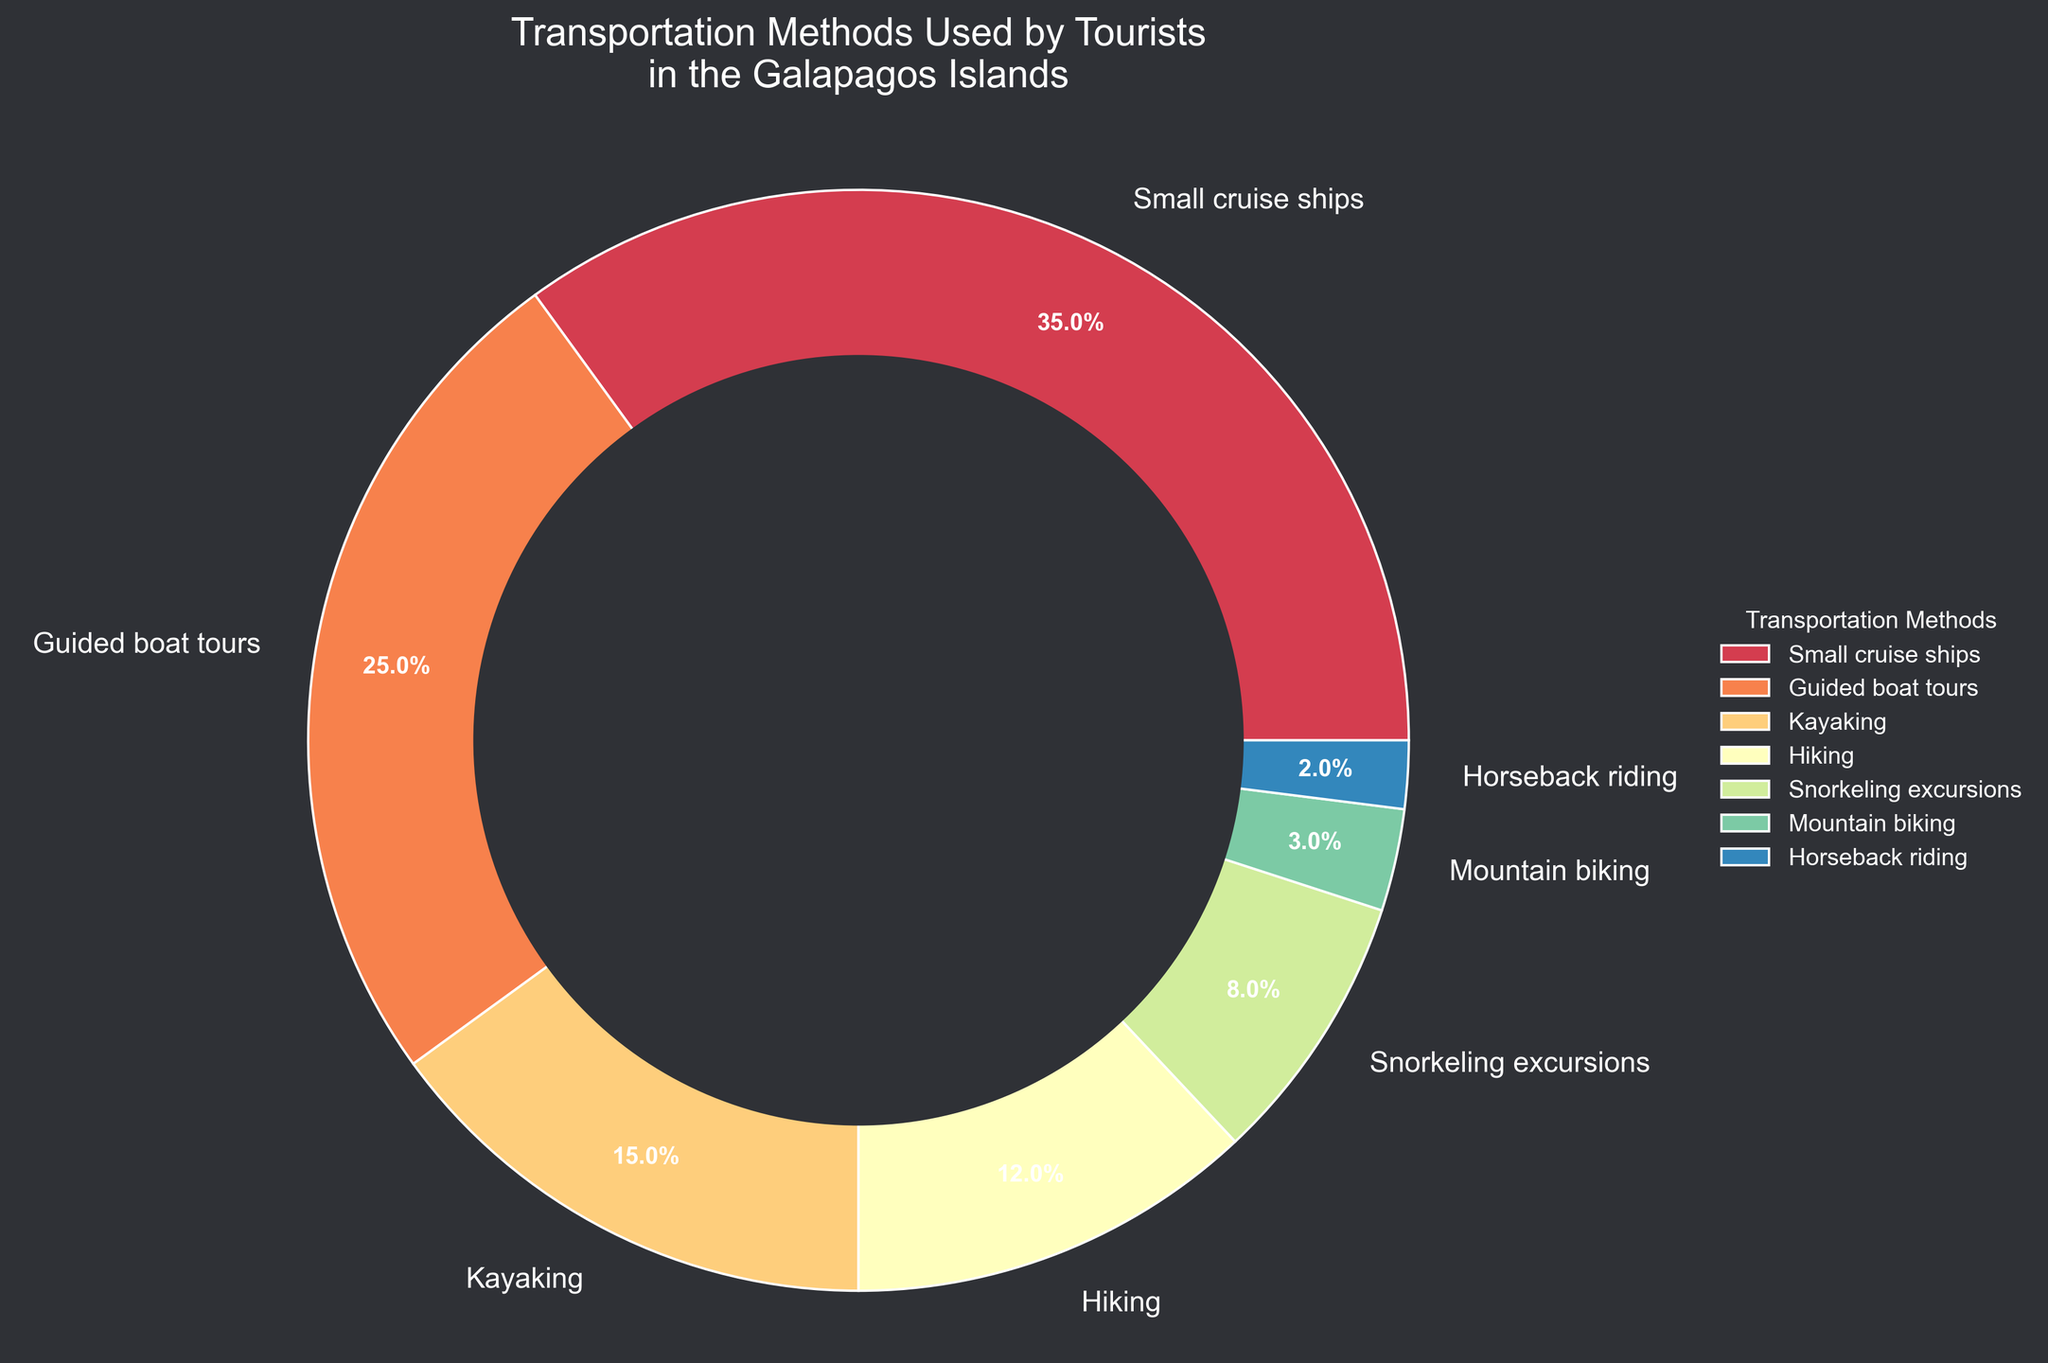What is the most common transportation method used by tourists in the Galapagos Islands? The largest segment on the pie chart represents "Small cruise ships" with 35%.
Answer: Small cruise ships What is the combined percentage of tourists who prefer kayaking, snorkeling excursions, and mountain biking? The percentages are 15%, 8%, and 3% respectively. Adding them up results in 15 + 8 + 3 = 26%.
Answer: 26% Which transportation method has a slightly higher usage percentage: hiking or snorkeling excursions? Hiking has a percentage of 12%, while snorkeling excursions have 8%. Therefore, hiking has a higher percentage.
Answer: Hiking How much larger is the percentage of tourists using guided boat tours compared to horseback riding? Guided boat tours account for 25% of tourists, while horseback riding accounts for 2%. The difference is 25 - 2 = 23%.
Answer: 23% What is the least used transportation method among tourists? The smallest segment on the pie chart represents "Horseback riding" with 2%.
Answer: Horseback riding If we combine the percentages of tourists using small cruise ships and guided boat tours, what fraction of the pie do they occupy? Small cruise ships account for 35% and guided boat tours for 25%. Combined, they make up 35 + 25 = 60%.
Answer: 60% Compare the usage percentages of kayaking and hiking. Which one is used more, and by how much? Kayaking usage is 15%, and hiking usage is 12%. Kayaking is used more by 15 - 12 = 3%.
Answer: 3% How do the percentages of tourists engaging in kayaking and mountain biking together compare to the percentage of tourists who use guided boat tours? Kayaking has 15% and mountain biking has 3%, together making 15 + 3 = 18%. This is less than the 25% of guided boat tours.
Answer: Less by 7% Which transportation method has a percentage closest to the combined percentage of hiking and snorkeling excursions? Hiking is 12% and snorkeling excursions are 8%, together making 12 + 8 = 20%. The closest method to 20% is guided boat tours at 25%.
Answer: Guided boat tours What is the difference between the usage percentage of small cruise ships and the next leading transportation method? Small cruise ships have 35%, the next leading method (guided boat tours) has 25%. The difference is 35 - 25 = 10%.
Answer: 10% 